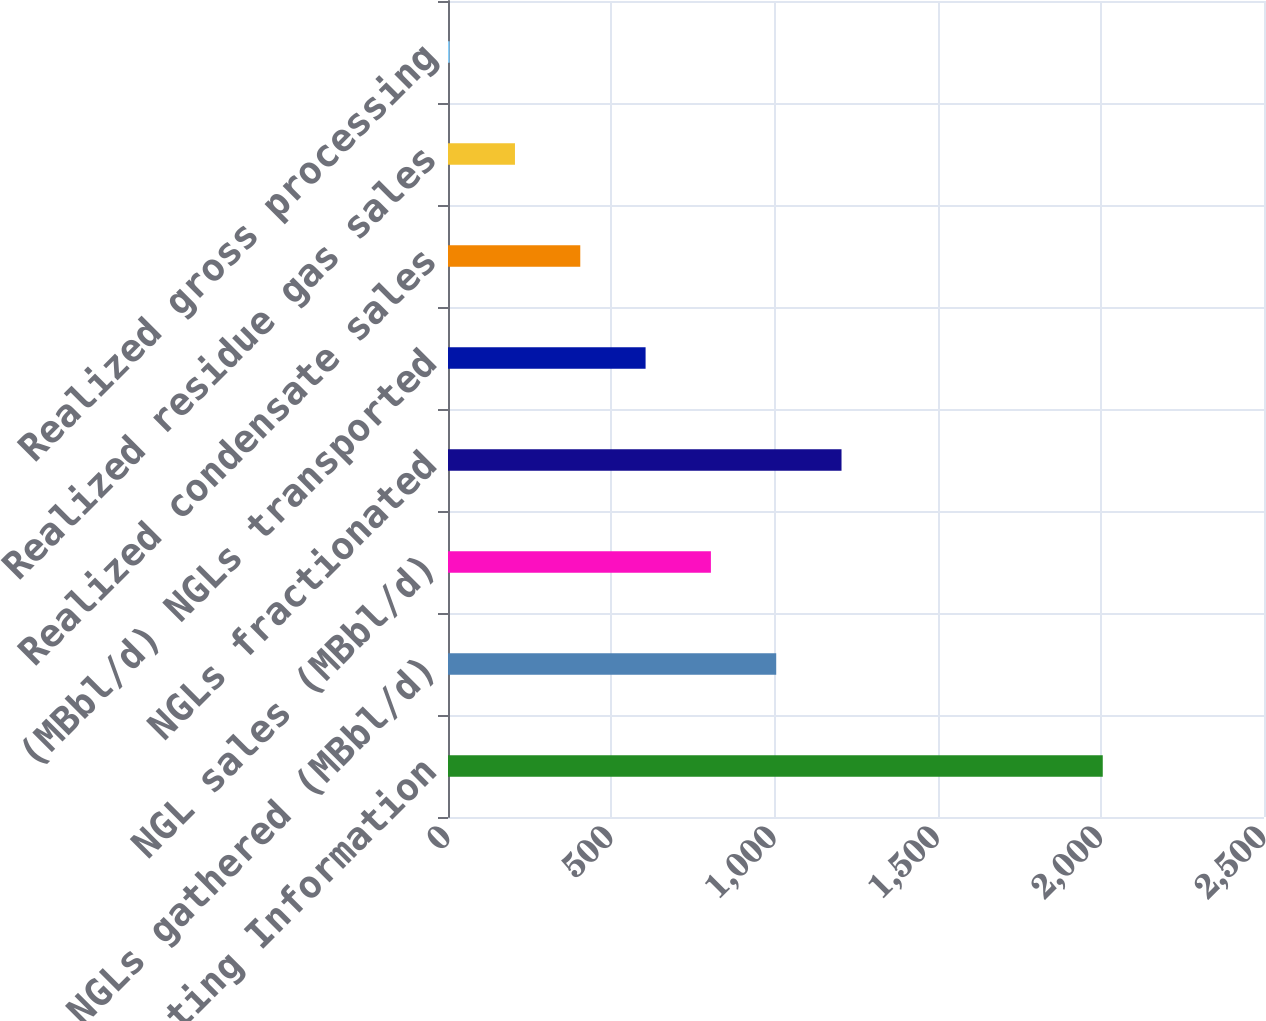Convert chart. <chart><loc_0><loc_0><loc_500><loc_500><bar_chart><fcel>Operating Information<fcel>NGLs gathered (MBbl/d)<fcel>NGL sales (MBbl/d)<fcel>NGLs fractionated<fcel>(MBbl/d) NGLs transported<fcel>Realized condensate sales<fcel>Realized residue gas sales<fcel>Realized gross processing<nl><fcel>2006<fcel>1005.55<fcel>805.45<fcel>1205.64<fcel>605.35<fcel>405.25<fcel>205.15<fcel>5.05<nl></chart> 